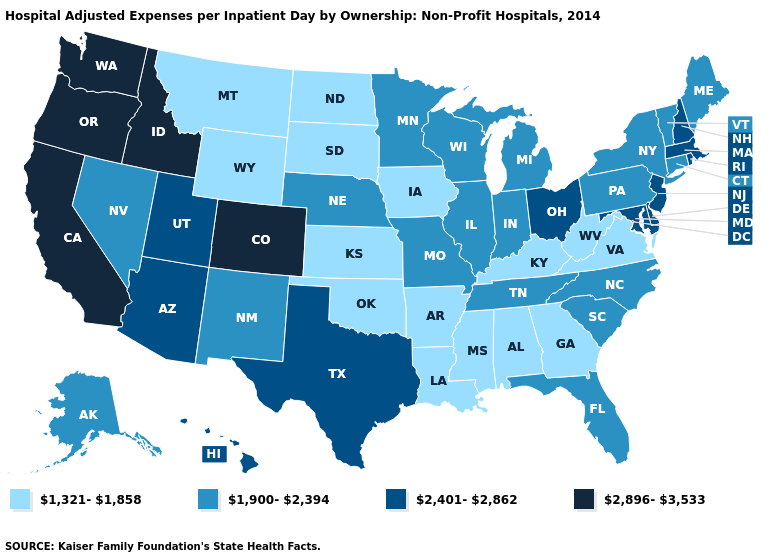Does Illinois have the same value as Delaware?
Short answer required. No. What is the value of Arizona?
Short answer required. 2,401-2,862. Does New Jersey have the highest value in the USA?
Short answer required. No. Among the states that border Illinois , which have the highest value?
Be succinct. Indiana, Missouri, Wisconsin. Which states have the lowest value in the Northeast?
Short answer required. Connecticut, Maine, New York, Pennsylvania, Vermont. What is the lowest value in the MidWest?
Concise answer only. 1,321-1,858. Does the map have missing data?
Short answer required. No. What is the highest value in states that border Kansas?
Concise answer only. 2,896-3,533. What is the value of Oklahoma?
Short answer required. 1,321-1,858. Which states have the highest value in the USA?
Quick response, please. California, Colorado, Idaho, Oregon, Washington. Which states have the lowest value in the MidWest?
Short answer required. Iowa, Kansas, North Dakota, South Dakota. Does Nebraska have the lowest value in the MidWest?
Give a very brief answer. No. What is the value of Alabama?
Short answer required. 1,321-1,858. Name the states that have a value in the range 2,401-2,862?
Short answer required. Arizona, Delaware, Hawaii, Maryland, Massachusetts, New Hampshire, New Jersey, Ohio, Rhode Island, Texas, Utah. Which states hav the highest value in the West?
Keep it brief. California, Colorado, Idaho, Oregon, Washington. 